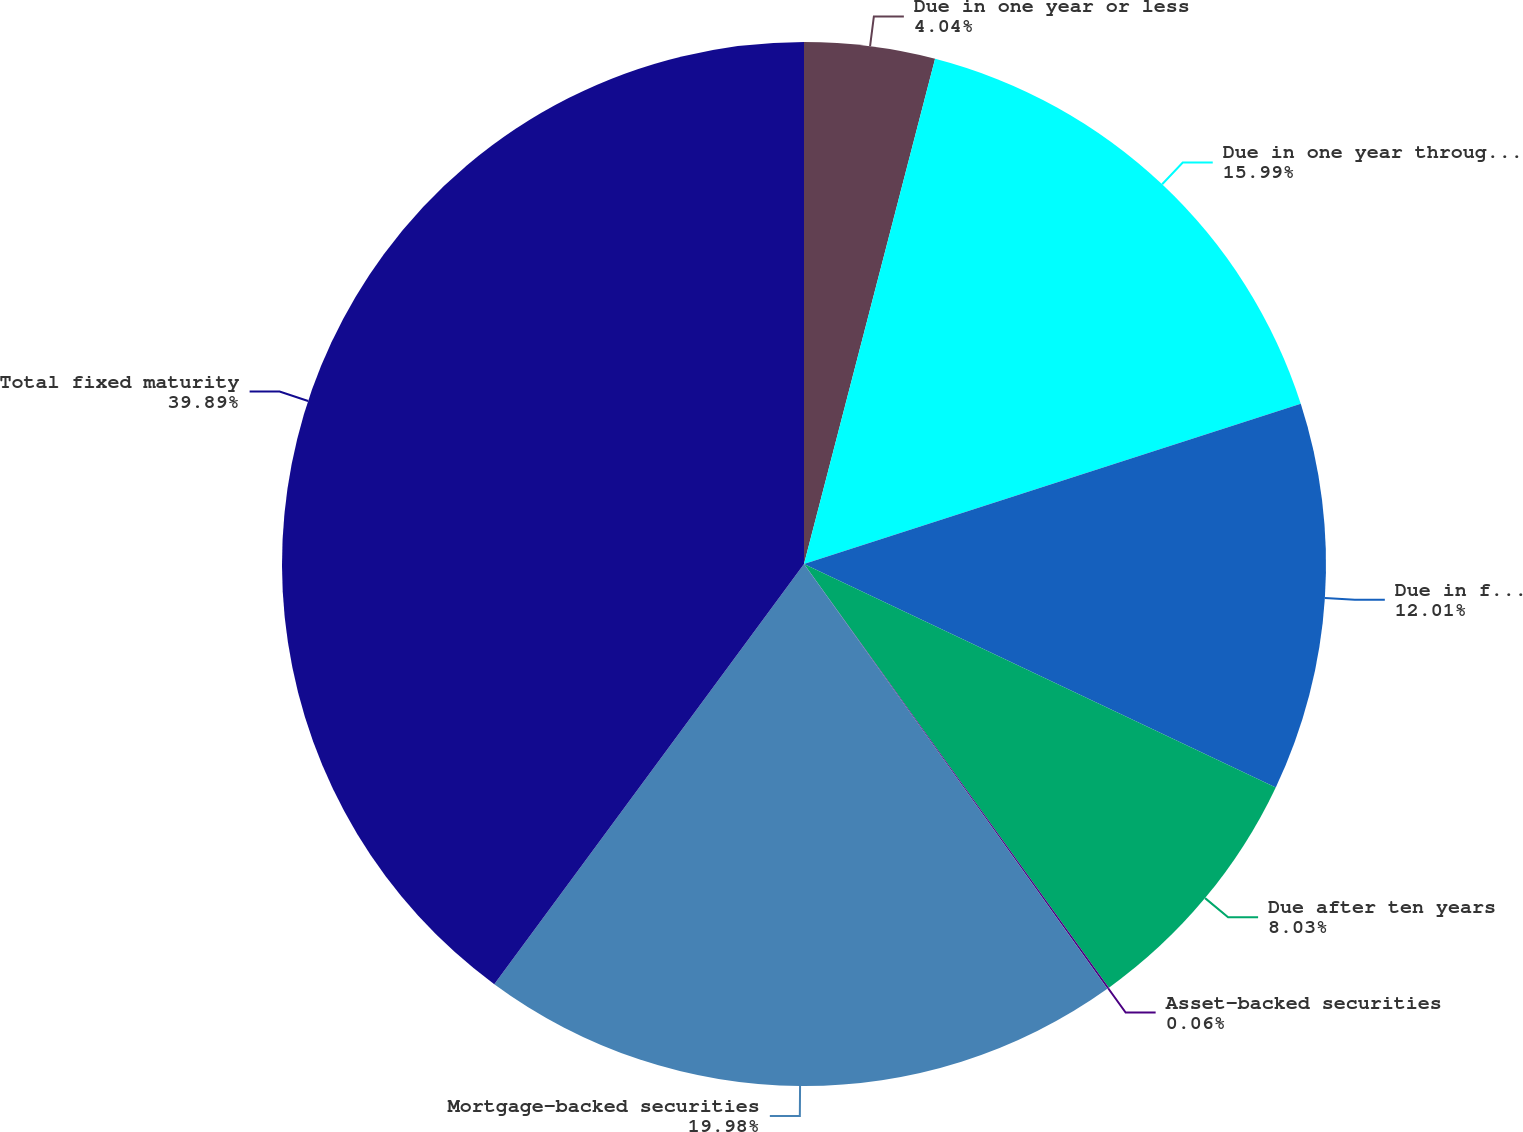Convert chart. <chart><loc_0><loc_0><loc_500><loc_500><pie_chart><fcel>Due in one year or less<fcel>Due in one year through five<fcel>Due in five years through ten<fcel>Due after ten years<fcel>Asset-backed securities<fcel>Mortgage-backed securities<fcel>Total fixed maturity<nl><fcel>4.04%<fcel>15.99%<fcel>12.01%<fcel>8.03%<fcel>0.06%<fcel>19.98%<fcel>39.89%<nl></chart> 